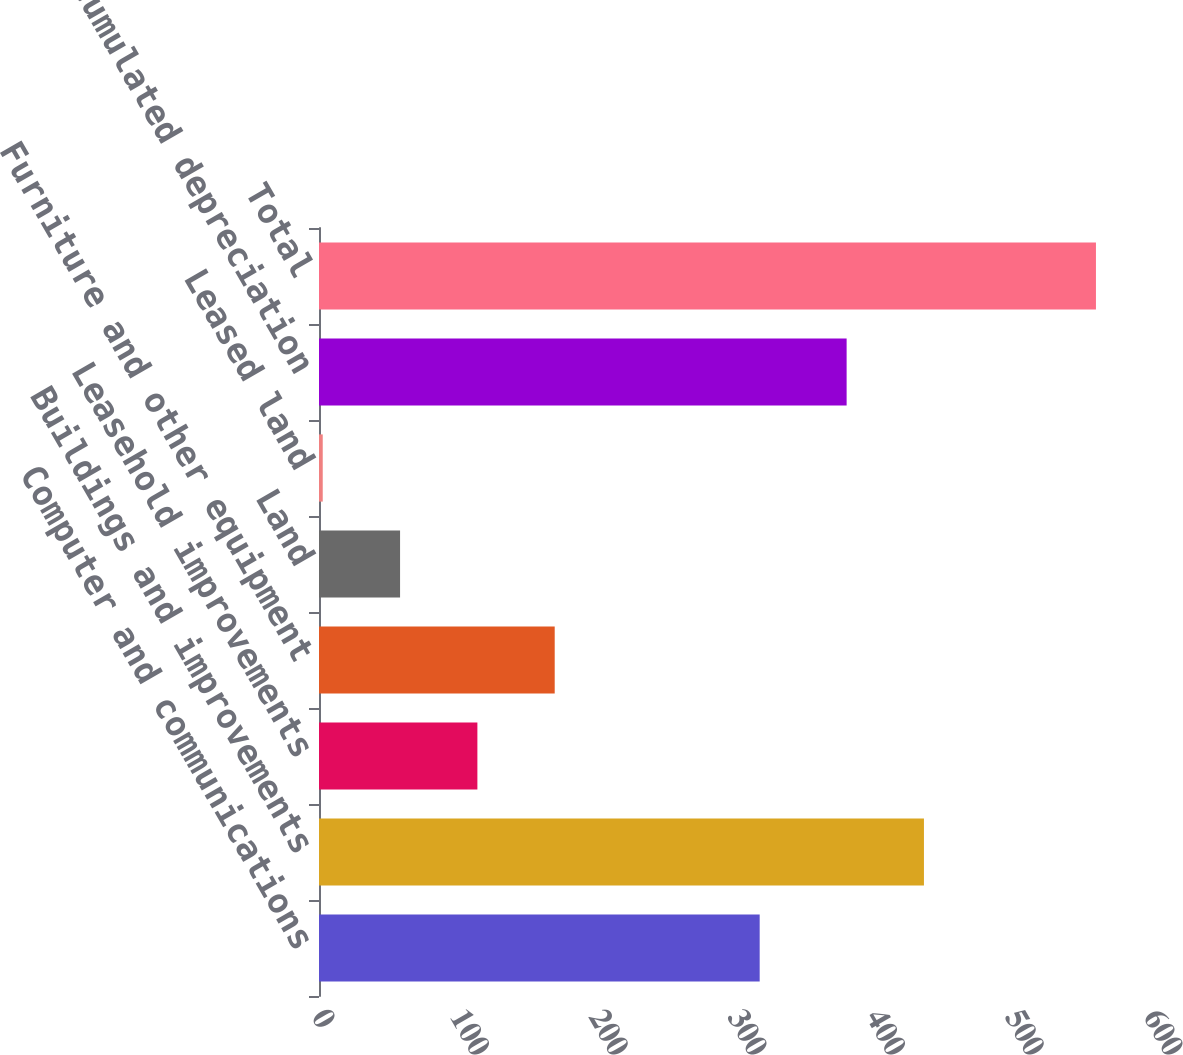Convert chart. <chart><loc_0><loc_0><loc_500><loc_500><bar_chart><fcel>Computer and communications<fcel>Buildings and improvements<fcel>Leasehold improvements<fcel>Furniture and other equipment<fcel>Land<fcel>Leased land<fcel>Less accumulated depreciation<fcel>Total<nl><fcel>317.8<fcel>436.26<fcel>114.22<fcel>169.98<fcel>58.46<fcel>2.7<fcel>380.5<fcel>560.3<nl></chart> 